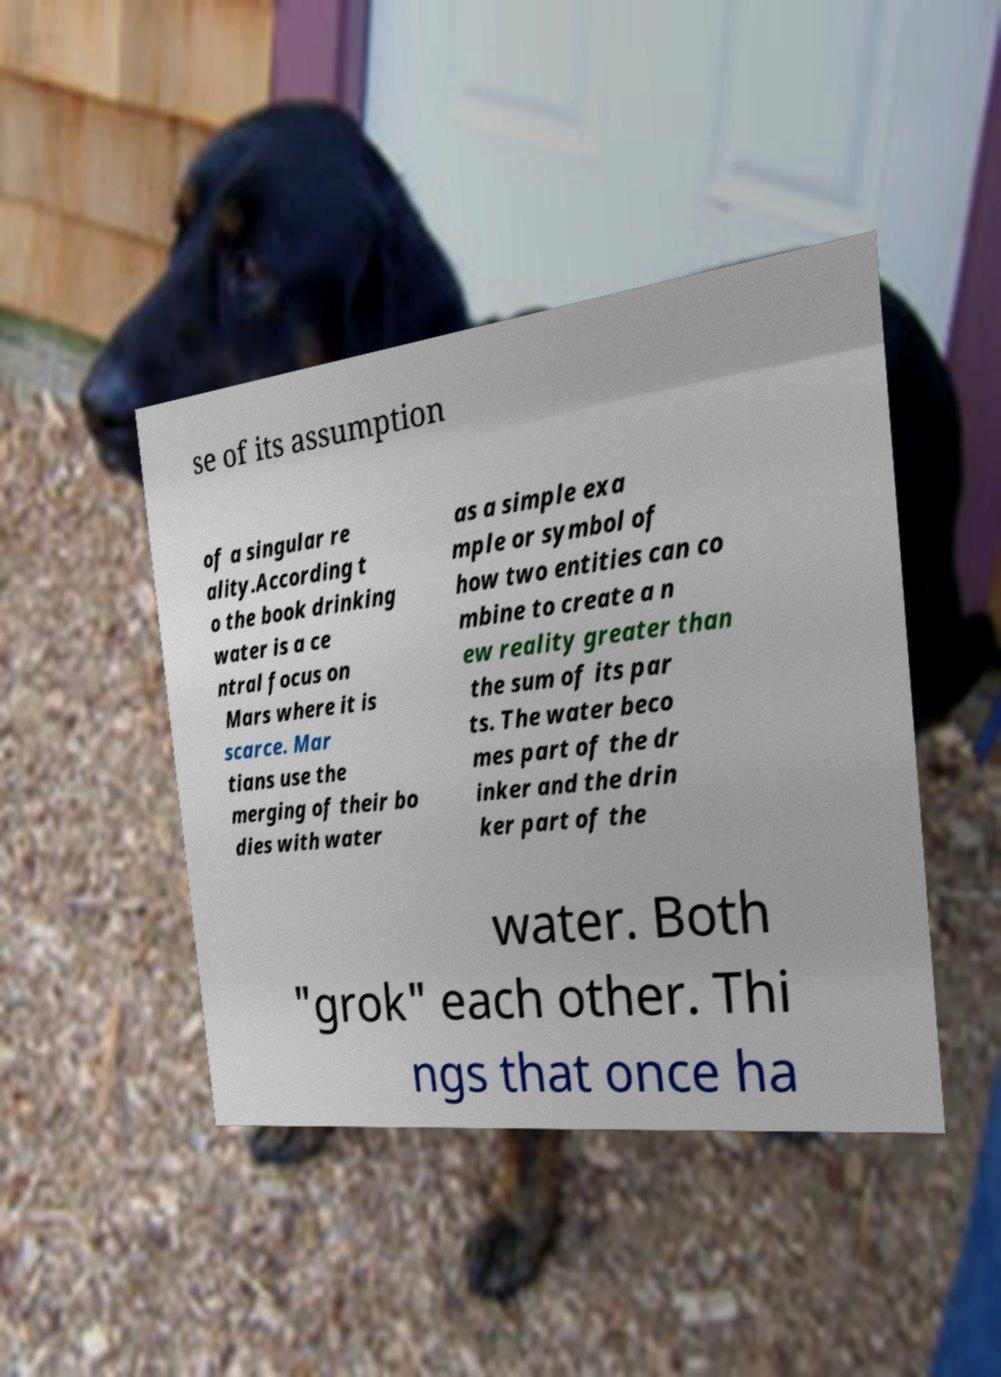There's text embedded in this image that I need extracted. Can you transcribe it verbatim? se of its assumption of a singular re ality.According t o the book drinking water is a ce ntral focus on Mars where it is scarce. Mar tians use the merging of their bo dies with water as a simple exa mple or symbol of how two entities can co mbine to create a n ew reality greater than the sum of its par ts. The water beco mes part of the dr inker and the drin ker part of the water. Both "grok" each other. Thi ngs that once ha 